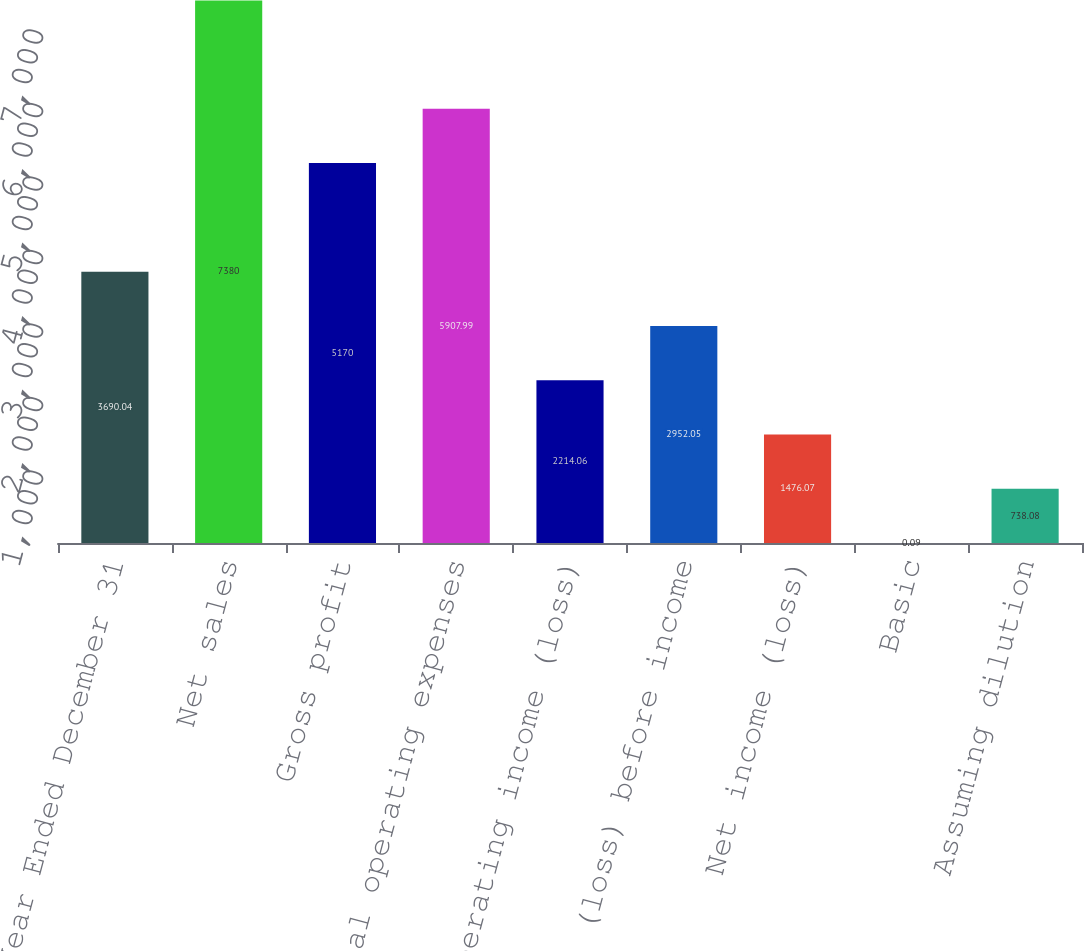Convert chart to OTSL. <chart><loc_0><loc_0><loc_500><loc_500><bar_chart><fcel>Year Ended December 31<fcel>Net sales<fcel>Gross profit<fcel>Total operating expenses<fcel>Operating income (loss)<fcel>Income (loss) before income<fcel>Net income (loss)<fcel>Basic<fcel>Assuming dilution<nl><fcel>3690.04<fcel>7380<fcel>5170<fcel>5907.99<fcel>2214.06<fcel>2952.05<fcel>1476.07<fcel>0.09<fcel>738.08<nl></chart> 